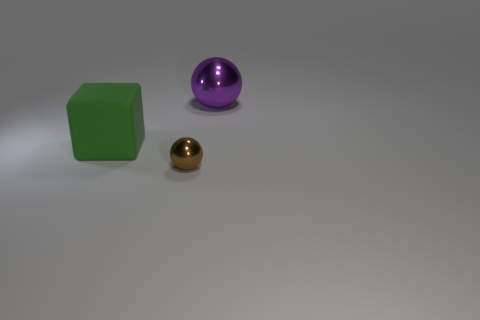Does the large object that is behind the big rubber cube have the same color as the large matte object?
Provide a short and direct response. No. Is there any other thing of the same color as the big matte block?
Provide a succinct answer. No. Are there more large metal things that are to the left of the big green block than small blue cubes?
Offer a very short reply. No. Do the green block and the purple metal ball have the same size?
Offer a terse response. Yes. What material is the large object that is the same shape as the small brown metal object?
Your response must be concise. Metal. Is there anything else that has the same material as the big purple object?
Offer a very short reply. Yes. How many green objects are small matte cylinders or big rubber things?
Your answer should be compact. 1. There is a sphere that is right of the small brown metallic sphere; what material is it?
Give a very brief answer. Metal. Are there more spheres than tiny cyan metallic cylinders?
Your answer should be compact. Yes. Is the shape of the big object that is behind the green cube the same as  the tiny metallic object?
Your answer should be very brief. Yes. 